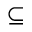Convert formula to latex. <formula><loc_0><loc_0><loc_500><loc_500>\subseteq</formula> 